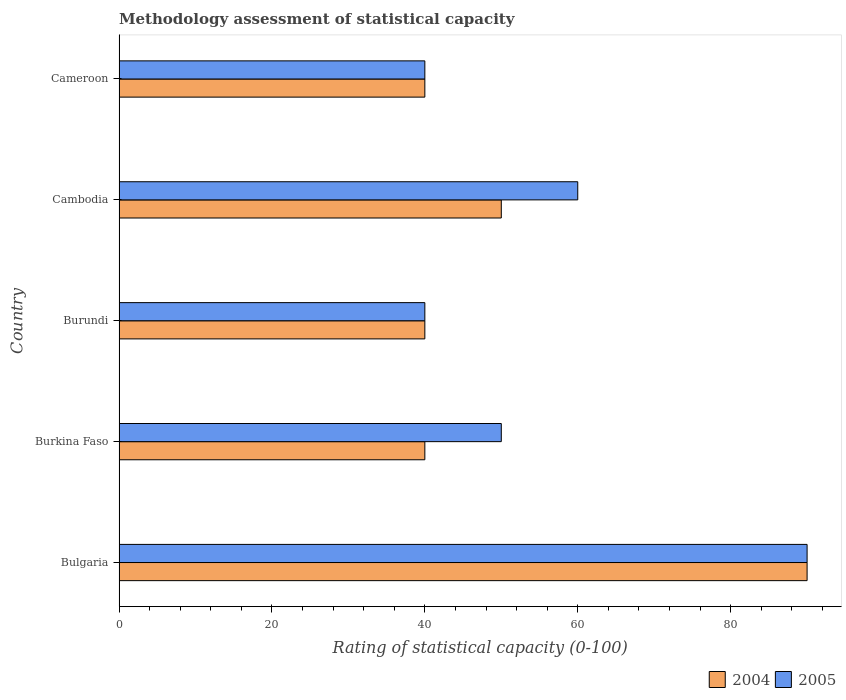How many bars are there on the 5th tick from the top?
Your response must be concise. 2. How many bars are there on the 2nd tick from the bottom?
Ensure brevity in your answer.  2. What is the label of the 1st group of bars from the top?
Your answer should be very brief. Cameroon. What is the rating of statistical capacity in 2005 in Bulgaria?
Make the answer very short. 90. Across all countries, what is the maximum rating of statistical capacity in 2005?
Offer a terse response. 90. Across all countries, what is the minimum rating of statistical capacity in 2005?
Make the answer very short. 40. In which country was the rating of statistical capacity in 2005 maximum?
Provide a succinct answer. Bulgaria. In which country was the rating of statistical capacity in 2005 minimum?
Offer a terse response. Burundi. What is the total rating of statistical capacity in 2005 in the graph?
Ensure brevity in your answer.  280. What is the difference between the rating of statistical capacity in 2005 in Burkina Faso and that in Cambodia?
Provide a succinct answer. -10. What is the difference between the rating of statistical capacity in 2005 and rating of statistical capacity in 2004 in Burundi?
Your answer should be very brief. 0. What is the difference between the highest and the lowest rating of statistical capacity in 2005?
Your answer should be compact. 50. In how many countries, is the rating of statistical capacity in 2005 greater than the average rating of statistical capacity in 2005 taken over all countries?
Your answer should be very brief. 2. Is the sum of the rating of statistical capacity in 2005 in Burkina Faso and Cameroon greater than the maximum rating of statistical capacity in 2004 across all countries?
Your response must be concise. No. How many bars are there?
Give a very brief answer. 10. Are the values on the major ticks of X-axis written in scientific E-notation?
Offer a terse response. No. How are the legend labels stacked?
Make the answer very short. Horizontal. What is the title of the graph?
Provide a succinct answer. Methodology assessment of statistical capacity. What is the label or title of the X-axis?
Provide a short and direct response. Rating of statistical capacity (0-100). What is the Rating of statistical capacity (0-100) in 2004 in Bulgaria?
Offer a terse response. 90. What is the Rating of statistical capacity (0-100) of 2005 in Bulgaria?
Offer a very short reply. 90. What is the Rating of statistical capacity (0-100) in 2004 in Burkina Faso?
Keep it short and to the point. 40. What is the Rating of statistical capacity (0-100) of 2005 in Burkina Faso?
Your answer should be compact. 50. What is the Rating of statistical capacity (0-100) in 2005 in Burundi?
Keep it short and to the point. 40. What is the Rating of statistical capacity (0-100) in 2004 in Cameroon?
Your response must be concise. 40. What is the total Rating of statistical capacity (0-100) in 2004 in the graph?
Give a very brief answer. 260. What is the total Rating of statistical capacity (0-100) in 2005 in the graph?
Keep it short and to the point. 280. What is the difference between the Rating of statistical capacity (0-100) in 2004 in Bulgaria and that in Burundi?
Offer a terse response. 50. What is the difference between the Rating of statistical capacity (0-100) of 2004 in Bulgaria and that in Cambodia?
Give a very brief answer. 40. What is the difference between the Rating of statistical capacity (0-100) in 2005 in Bulgaria and that in Cameroon?
Keep it short and to the point. 50. What is the difference between the Rating of statistical capacity (0-100) in 2004 in Burkina Faso and that in Cambodia?
Keep it short and to the point. -10. What is the difference between the Rating of statistical capacity (0-100) in 2005 in Burkina Faso and that in Cameroon?
Give a very brief answer. 10. What is the difference between the Rating of statistical capacity (0-100) in 2004 in Cambodia and that in Cameroon?
Offer a very short reply. 10. What is the difference between the Rating of statistical capacity (0-100) in 2004 in Bulgaria and the Rating of statistical capacity (0-100) in 2005 in Burkina Faso?
Provide a short and direct response. 40. What is the difference between the Rating of statistical capacity (0-100) of 2004 in Bulgaria and the Rating of statistical capacity (0-100) of 2005 in Burundi?
Give a very brief answer. 50. What is the difference between the Rating of statistical capacity (0-100) of 2004 in Burkina Faso and the Rating of statistical capacity (0-100) of 2005 in Burundi?
Your response must be concise. 0. What is the difference between the Rating of statistical capacity (0-100) of 2004 in Burkina Faso and the Rating of statistical capacity (0-100) of 2005 in Cambodia?
Provide a short and direct response. -20. What is the difference between the Rating of statistical capacity (0-100) of 2004 in Burkina Faso and the Rating of statistical capacity (0-100) of 2005 in Cameroon?
Provide a succinct answer. 0. What is the difference between the Rating of statistical capacity (0-100) of 2004 in Burundi and the Rating of statistical capacity (0-100) of 2005 in Cambodia?
Your answer should be very brief. -20. What is the difference between the Rating of statistical capacity (0-100) of 2004 in Burundi and the Rating of statistical capacity (0-100) of 2005 in Cameroon?
Your answer should be very brief. 0. What is the average Rating of statistical capacity (0-100) in 2004 per country?
Give a very brief answer. 52. What is the average Rating of statistical capacity (0-100) in 2005 per country?
Give a very brief answer. 56. What is the difference between the Rating of statistical capacity (0-100) of 2004 and Rating of statistical capacity (0-100) of 2005 in Bulgaria?
Offer a very short reply. 0. What is the difference between the Rating of statistical capacity (0-100) in 2004 and Rating of statistical capacity (0-100) in 2005 in Burkina Faso?
Your response must be concise. -10. What is the difference between the Rating of statistical capacity (0-100) in 2004 and Rating of statistical capacity (0-100) in 2005 in Burundi?
Give a very brief answer. 0. What is the difference between the Rating of statistical capacity (0-100) of 2004 and Rating of statistical capacity (0-100) of 2005 in Cameroon?
Offer a very short reply. 0. What is the ratio of the Rating of statistical capacity (0-100) in 2004 in Bulgaria to that in Burkina Faso?
Your answer should be very brief. 2.25. What is the ratio of the Rating of statistical capacity (0-100) in 2004 in Bulgaria to that in Burundi?
Your response must be concise. 2.25. What is the ratio of the Rating of statistical capacity (0-100) in 2005 in Bulgaria to that in Burundi?
Your answer should be very brief. 2.25. What is the ratio of the Rating of statistical capacity (0-100) of 2005 in Bulgaria to that in Cambodia?
Keep it short and to the point. 1.5. What is the ratio of the Rating of statistical capacity (0-100) in 2004 in Bulgaria to that in Cameroon?
Your response must be concise. 2.25. What is the ratio of the Rating of statistical capacity (0-100) in 2005 in Bulgaria to that in Cameroon?
Give a very brief answer. 2.25. What is the ratio of the Rating of statistical capacity (0-100) in 2004 in Burkina Faso to that in Cambodia?
Provide a short and direct response. 0.8. What is the ratio of the Rating of statistical capacity (0-100) of 2005 in Burkina Faso to that in Cambodia?
Keep it short and to the point. 0.83. What is the ratio of the Rating of statistical capacity (0-100) in 2004 in Burkina Faso to that in Cameroon?
Provide a short and direct response. 1. What is the ratio of the Rating of statistical capacity (0-100) in 2005 in Burundi to that in Cambodia?
Offer a very short reply. 0.67. What is the ratio of the Rating of statistical capacity (0-100) of 2005 in Burundi to that in Cameroon?
Your response must be concise. 1. What is the ratio of the Rating of statistical capacity (0-100) in 2004 in Cambodia to that in Cameroon?
Give a very brief answer. 1.25. What is the ratio of the Rating of statistical capacity (0-100) in 2005 in Cambodia to that in Cameroon?
Offer a very short reply. 1.5. What is the difference between the highest and the lowest Rating of statistical capacity (0-100) in 2004?
Keep it short and to the point. 50. What is the difference between the highest and the lowest Rating of statistical capacity (0-100) in 2005?
Provide a succinct answer. 50. 